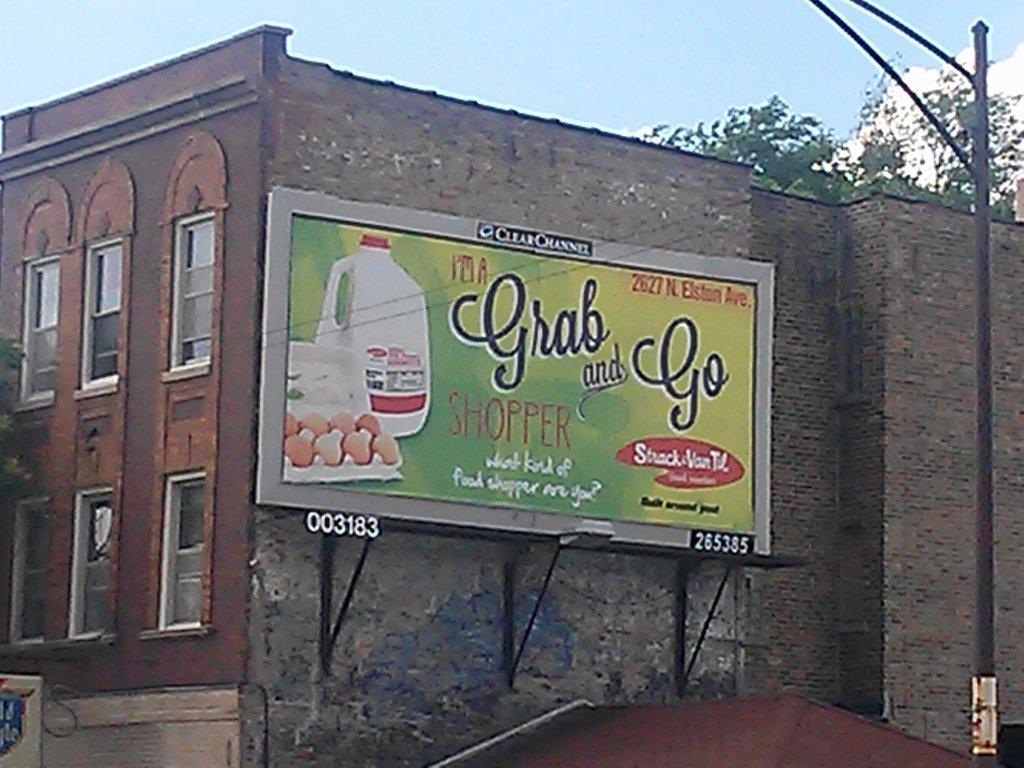<image>
Share a concise interpretation of the image provided. A billboard for Grag and Go Shopper is on the side of a building. 